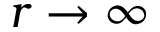Convert formula to latex. <formula><loc_0><loc_0><loc_500><loc_500>r \to \infty</formula> 